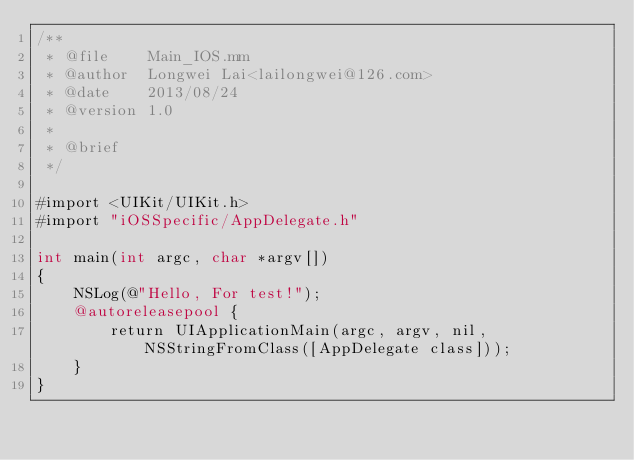Convert code to text. <code><loc_0><loc_0><loc_500><loc_500><_ObjectiveC_>/**
 * @file    Main_IOS.mm
 * @author  Longwei Lai<lailongwei@126.com>
 * @date    2013/08/24
 * @version 1.0
 *
 * @brief
 */

#import <UIKit/UIKit.h>
#import "iOSSpecific/AppDelegate.h"

int main(int argc, char *argv[])
{
    NSLog(@"Hello, For test!");
    @autoreleasepool {
        return UIApplicationMain(argc, argv, nil, NSStringFromClass([AppDelegate class]));
    }
}
</code> 